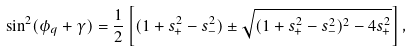<formula> <loc_0><loc_0><loc_500><loc_500>\sin ^ { 2 } ( \phi _ { q } + \gamma ) = \frac { 1 } { 2 } \left [ ( 1 + s _ { + } ^ { 2 } - s _ { - } ^ { 2 } ) \pm \sqrt { ( 1 + s _ { + } ^ { 2 } - s _ { - } ^ { 2 } ) ^ { 2 } - 4 s _ { + } ^ { 2 } } \right ] ,</formula> 